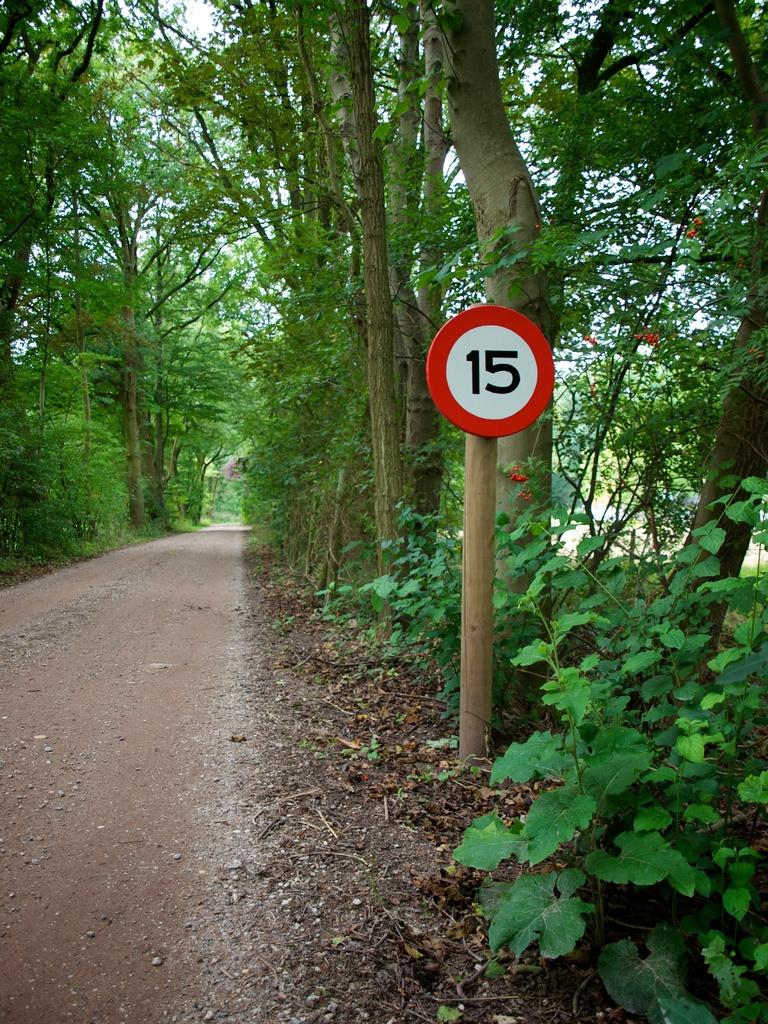What is the speed limit for this road?
Offer a very short reply. 15. 